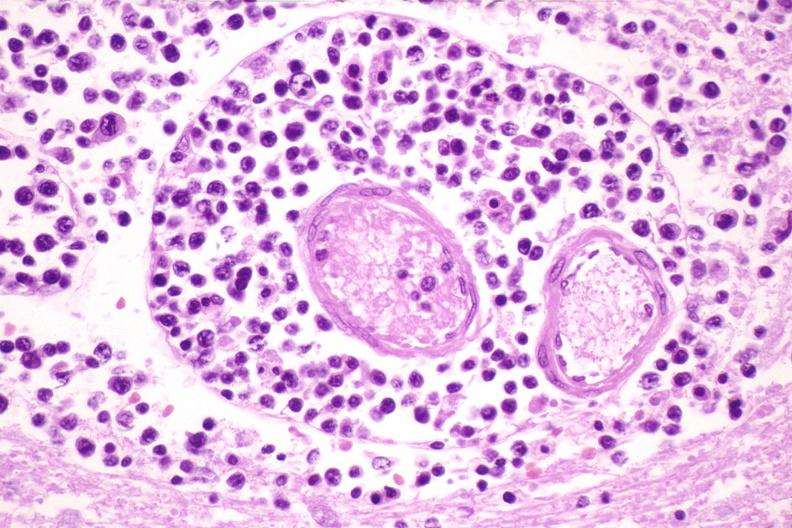does this typical lesion show brain lymphoma?
Answer the question using a single word or phrase. No 